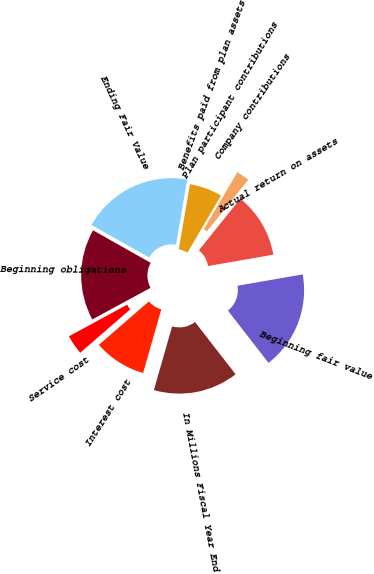<chart> <loc_0><loc_0><loc_500><loc_500><pie_chart><fcel>In Millions Fiscal Year End<fcel>Beginning fair value<fcel>Actual return on assets<fcel>Company contributions<fcel>Plan participant contributions<fcel>Benefits paid from plan assets<fcel>Ending Fair Value<fcel>Beginning obligations<fcel>Service cost<fcel>Interest cost<nl><fcel>14.94%<fcel>17.24%<fcel>11.49%<fcel>2.3%<fcel>0.0%<fcel>5.75%<fcel>19.54%<fcel>16.09%<fcel>3.45%<fcel>9.2%<nl></chart> 